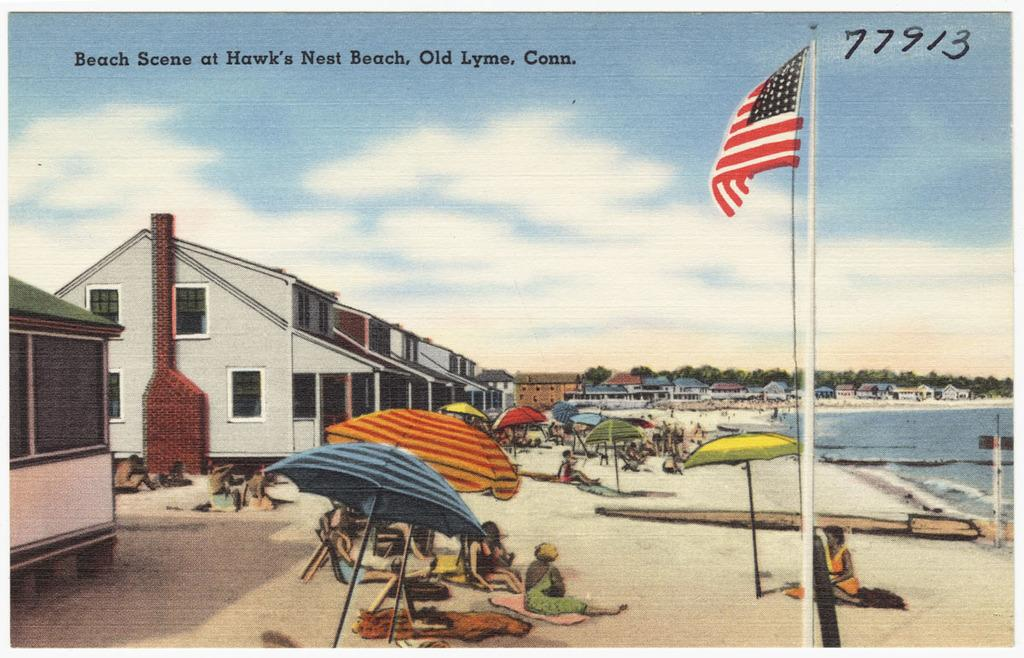How many persons are in the image? There are persons in the image. What objects are being used by the persons in the image? There are umbrellas in the image. What type of structures can be seen in the image? There are houses in the image. What is the tall, vertical object in the image? There is a flagpole in the image. What type of vegetation is present in the image? There are trees in the image. What natural element is visible in the image? There is water visible in the image. What is visible in the background of the image? The sky is visible in the background of the image. What can be seen in the sky? There are clouds in the sky. Can you tell me how many wounds are visible on the girl in the image? There is no girl present in the image, and therefore no wounds can be observed. What type of jar is being used to collect rainwater in the image? There is no jar present in the image, and no rainwater is being collected. 